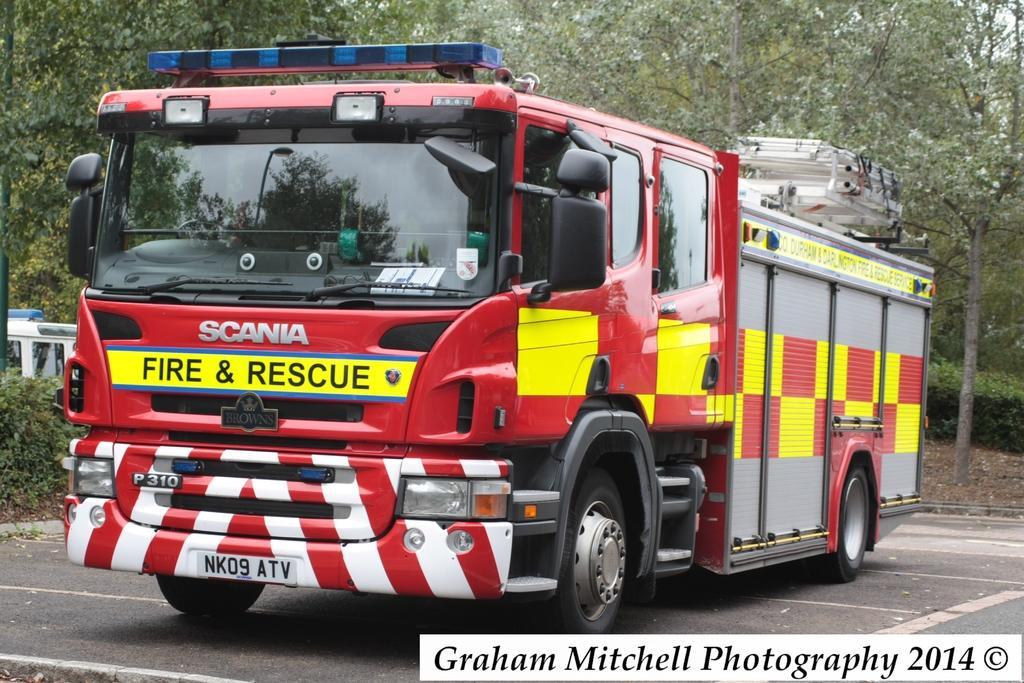Describe this image in one or two sentences. In this image there is a vehicle, there is the road, there are trees truncated towards the top of the image, there is a vehicle truncated towards the left of the image, there are plants truncated towards the left of the image, there are plants truncated towards the right of the image, there is text towards the bottom of the image. 